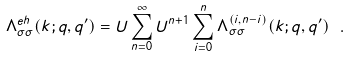<formula> <loc_0><loc_0><loc_500><loc_500>\Lambda _ { \sigma \sigma } ^ { e h } ( k ; q , q ^ { \prime } ) = U \sum _ { n = 0 } ^ { \infty } U ^ { n + 1 } \sum _ { i = 0 } ^ { n } \Lambda _ { \sigma \sigma } ^ { ( i , n - i ) } ( k ; q , q ^ { \prime } ) \ .</formula> 